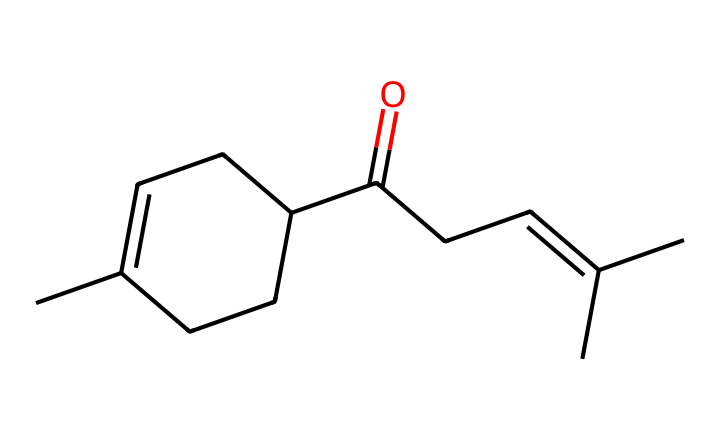How many carbon atoms are in jasmone? By examining the molecular structure represented by the SMILES notation, each 'C' represents a carbon atom. Counting all carbon atoms in the formula gives a total of 15 carbon atoms.
Answer: 15 What is the functional group present in jasmone? Jasmone contains a carbonyl group (C=O), which is characteristic of ketones. This group can be identified from the structure, where the carbon is double-bonded to oxygen.
Answer: carbonyl What is the total number of hydrogen atoms in jasmone? To find the number of hydrogen atoms, we can use the general formula for aliphatic compounds: CnH(2n+2). For 15 carbons, it would be 2(15)+2, giving us 32 hydrogen atoms. However, since this molecule has a carbonyl group, we subtract two hydrogens, resulting in 30 hydrogen atoms.
Answer: 30 Which ring structure is present in jasmone? The structure includes a cyclohexane ring (a six-membered carbon ring), which can be identified by its closed loop of carbon atoms in the SMILES.
Answer: cyclohexane What type of isomerism does jasmone exhibit? Jasmone exhibits geometric isomerism due to the presence of a double bond (C=C) in the structure, allowing for different spatial arrangements of the atoms around the double bond.
Answer: geometric isomerism How many double bonds are present in jasmone? The SMILES structure reveals that there are two double bonds in total: one in the carbonyl group and another in the alkene, indicating two distinct regions of unsaturation.
Answer: 2 